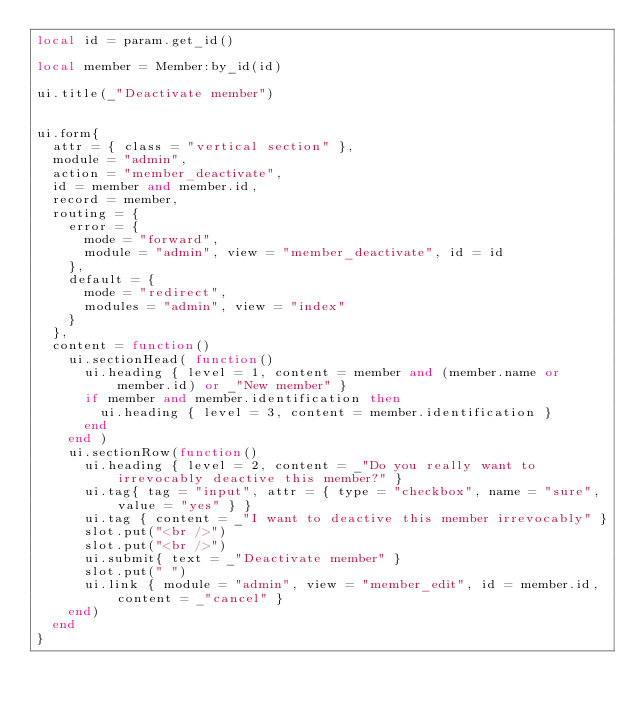<code> <loc_0><loc_0><loc_500><loc_500><_Lua_>local id = param.get_id()

local member = Member:by_id(id)

ui.title(_"Deactivate member")


ui.form{
  attr = { class = "vertical section" },
  module = "admin",
  action = "member_deactivate",
  id = member and member.id,
  record = member,
  routing = {
    error = {
      mode = "forward",
      module = "admin", view = "member_deactivate", id = id
    },
    default = {
      mode = "redirect",
      modules = "admin", view = "index"
    }
  },
  content = function()
    ui.sectionHead( function()
      ui.heading { level = 1, content = member and (member.name or member.id) or _"New member" }
      if member and member.identification then
        ui.heading { level = 3, content = member.identification }
      end
    end )
    ui.sectionRow(function()
      ui.heading { level = 2, content = _"Do you really want to irrevocably deactive this member?" }
      ui.tag{ tag = "input", attr = { type = "checkbox", name = "sure", value = "yes" } }
      ui.tag { content = _"I want to deactive this member irrevocably" }
      slot.put("<br />")
      slot.put("<br />")
      ui.submit{ text = _"Deactivate member" }
      slot.put(" ")
      ui.link { module = "admin", view = "member_edit", id = member.id, content = _"cancel" }
    end)
  end
}

</code> 